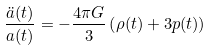Convert formula to latex. <formula><loc_0><loc_0><loc_500><loc_500>\frac { \ddot { a } ( t ) } { a ( t ) } = - \frac { 4 \pi G } { 3 } \left ( \rho ( t ) + 3 p ( t ) \right )</formula> 